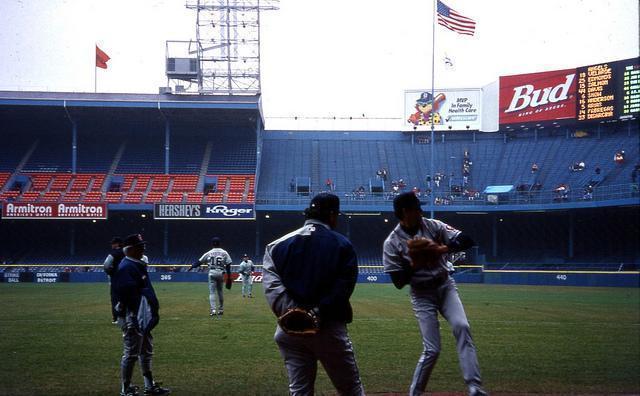Which advertiser is a watch company?
Select the accurate response from the four choices given to answer the question.
Options: Armitron, bud, hershey's, kroger. Armitron. 